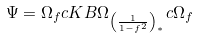Convert formula to latex. <formula><loc_0><loc_0><loc_500><loc_500>\Psi = \Omega _ { f } c K B \Omega _ { \left ( \frac { 1 } { 1 - f ^ { 2 } } \right ) _ { ^ { * } } } c \Omega _ { f }</formula> 